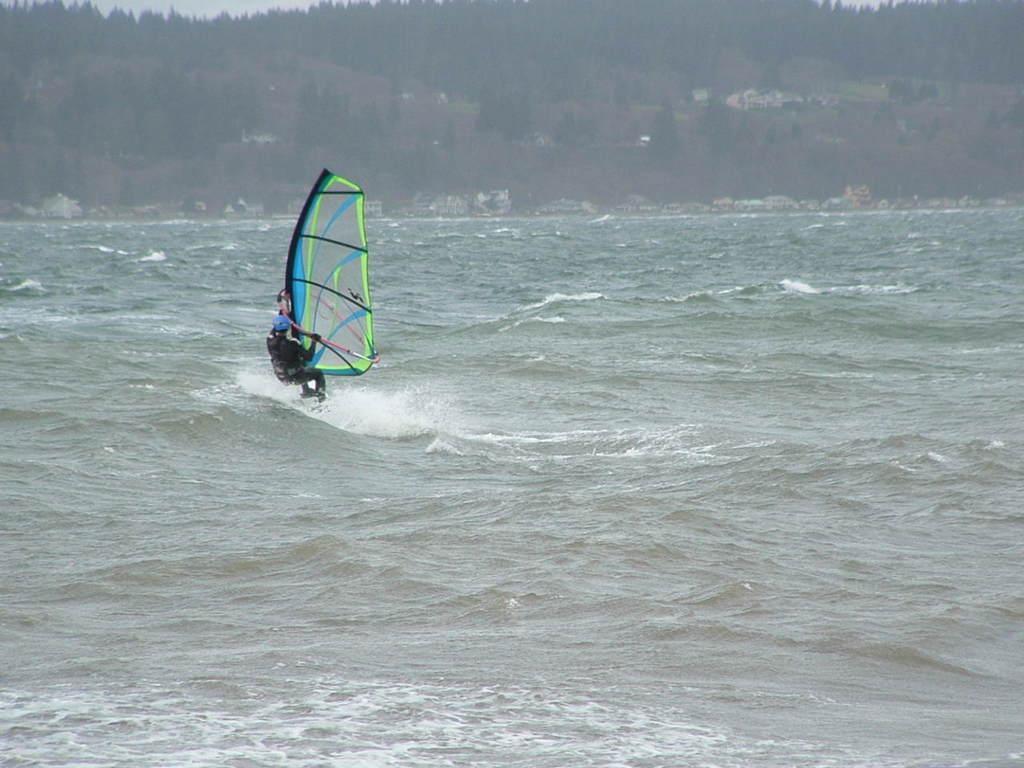Can you describe this image briefly? In this image it looks a sea. There is a person sailing boat in the foreground. There are some trees in the background. The sky is at the top and there is a water flow at the bottom 